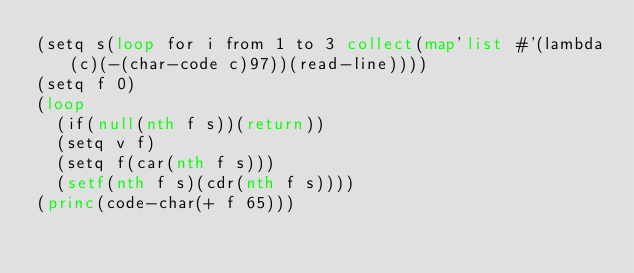Convert code to text. <code><loc_0><loc_0><loc_500><loc_500><_Lisp_>(setq s(loop for i from 1 to 3 collect(map'list #'(lambda(c)(-(char-code c)97))(read-line))))
(setq f 0)
(loop
  (if(null(nth f s))(return))
  (setq v f)
  (setq f(car(nth f s)))
  (setf(nth f s)(cdr(nth f s))))
(princ(code-char(+ f 65)))</code> 